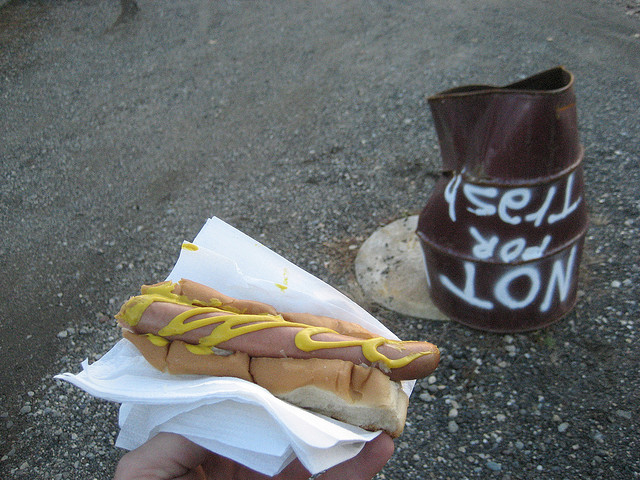Identify the text displayed in this image. Tresh POR N0T 